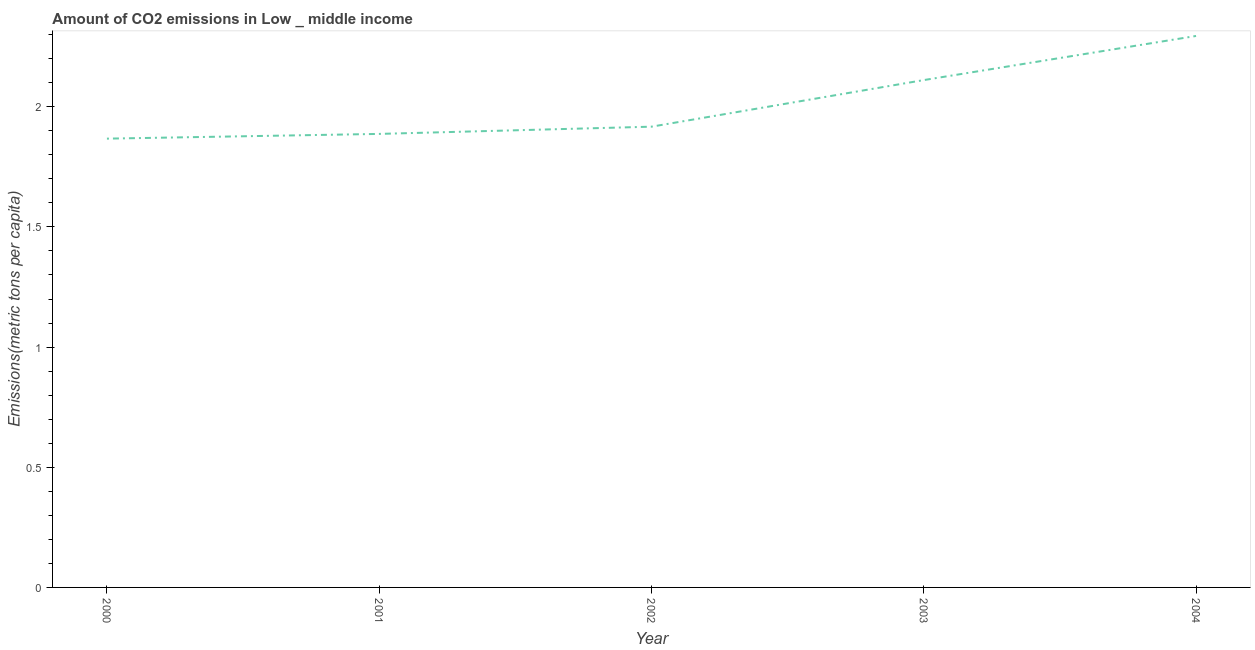What is the amount of co2 emissions in 2003?
Provide a succinct answer. 2.11. Across all years, what is the maximum amount of co2 emissions?
Give a very brief answer. 2.29. Across all years, what is the minimum amount of co2 emissions?
Your response must be concise. 1.87. In which year was the amount of co2 emissions maximum?
Make the answer very short. 2004. In which year was the amount of co2 emissions minimum?
Make the answer very short. 2000. What is the sum of the amount of co2 emissions?
Provide a succinct answer. 10.08. What is the difference between the amount of co2 emissions in 2001 and 2004?
Give a very brief answer. -0.41. What is the average amount of co2 emissions per year?
Keep it short and to the point. 2.02. What is the median amount of co2 emissions?
Your answer should be compact. 1.92. What is the ratio of the amount of co2 emissions in 2002 to that in 2003?
Provide a succinct answer. 0.91. Is the amount of co2 emissions in 2002 less than that in 2004?
Offer a terse response. Yes. What is the difference between the highest and the second highest amount of co2 emissions?
Your answer should be very brief. 0.18. Is the sum of the amount of co2 emissions in 2001 and 2004 greater than the maximum amount of co2 emissions across all years?
Offer a terse response. Yes. What is the difference between the highest and the lowest amount of co2 emissions?
Provide a succinct answer. 0.43. In how many years, is the amount of co2 emissions greater than the average amount of co2 emissions taken over all years?
Make the answer very short. 2. Does the amount of co2 emissions monotonically increase over the years?
Provide a short and direct response. Yes. What is the difference between two consecutive major ticks on the Y-axis?
Keep it short and to the point. 0.5. Are the values on the major ticks of Y-axis written in scientific E-notation?
Give a very brief answer. No. What is the title of the graph?
Ensure brevity in your answer.  Amount of CO2 emissions in Low _ middle income. What is the label or title of the Y-axis?
Offer a very short reply. Emissions(metric tons per capita). What is the Emissions(metric tons per capita) in 2000?
Your response must be concise. 1.87. What is the Emissions(metric tons per capita) of 2001?
Provide a short and direct response. 1.89. What is the Emissions(metric tons per capita) of 2002?
Offer a terse response. 1.92. What is the Emissions(metric tons per capita) in 2003?
Make the answer very short. 2.11. What is the Emissions(metric tons per capita) in 2004?
Your response must be concise. 2.29. What is the difference between the Emissions(metric tons per capita) in 2000 and 2001?
Keep it short and to the point. -0.02. What is the difference between the Emissions(metric tons per capita) in 2000 and 2002?
Make the answer very short. -0.05. What is the difference between the Emissions(metric tons per capita) in 2000 and 2003?
Offer a very short reply. -0.24. What is the difference between the Emissions(metric tons per capita) in 2000 and 2004?
Offer a very short reply. -0.43. What is the difference between the Emissions(metric tons per capita) in 2001 and 2002?
Provide a succinct answer. -0.03. What is the difference between the Emissions(metric tons per capita) in 2001 and 2003?
Make the answer very short. -0.22. What is the difference between the Emissions(metric tons per capita) in 2001 and 2004?
Ensure brevity in your answer.  -0.41. What is the difference between the Emissions(metric tons per capita) in 2002 and 2003?
Ensure brevity in your answer.  -0.19. What is the difference between the Emissions(metric tons per capita) in 2002 and 2004?
Give a very brief answer. -0.38. What is the difference between the Emissions(metric tons per capita) in 2003 and 2004?
Offer a terse response. -0.18. What is the ratio of the Emissions(metric tons per capita) in 2000 to that in 2002?
Keep it short and to the point. 0.97. What is the ratio of the Emissions(metric tons per capita) in 2000 to that in 2003?
Ensure brevity in your answer.  0.89. What is the ratio of the Emissions(metric tons per capita) in 2000 to that in 2004?
Make the answer very short. 0.81. What is the ratio of the Emissions(metric tons per capita) in 2001 to that in 2002?
Your answer should be compact. 0.98. What is the ratio of the Emissions(metric tons per capita) in 2001 to that in 2003?
Offer a very short reply. 0.89. What is the ratio of the Emissions(metric tons per capita) in 2001 to that in 2004?
Offer a terse response. 0.82. What is the ratio of the Emissions(metric tons per capita) in 2002 to that in 2003?
Ensure brevity in your answer.  0.91. What is the ratio of the Emissions(metric tons per capita) in 2002 to that in 2004?
Provide a short and direct response. 0.84. What is the ratio of the Emissions(metric tons per capita) in 2003 to that in 2004?
Give a very brief answer. 0.92. 